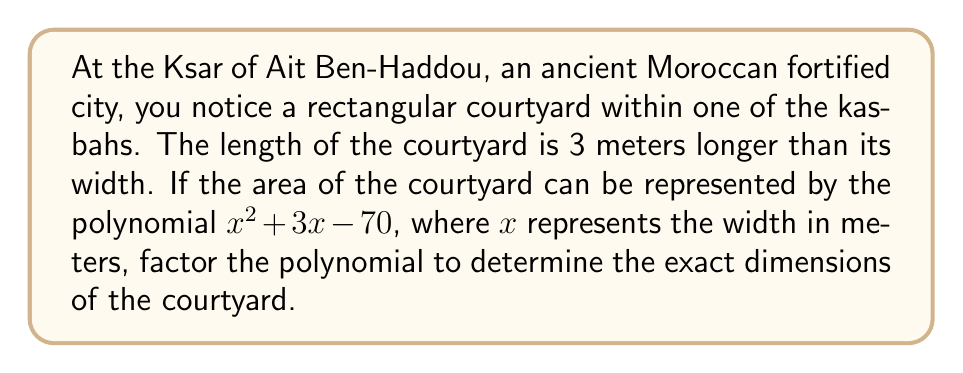What is the answer to this math problem? To solve this problem, we need to factor the given polynomial $x^2 + 3x - 70$ and interpret the results in the context of the courtyard's dimensions.

Step 1: Identify the polynomial
We have $ax^2 + bx + c$ where $a=1$, $b=3$, and $c=-70$.

Step 2: Use the ac-method for factoring
1) Multiply $a \cdot c = 1 \cdot (-70) = -70$
2) Find two numbers that multiply to give -70 and add to give 3 (the coefficient of x)
   These numbers are 10 and -7

Step 3: Rewrite the middle term
$x^2 + 3x - 70 = x^2 + 10x - 7x - 70$

Step 4: Factor by grouping
$(x^2 + 10x) + (-7x - 70)$
$x(x + 10) - 7(x + 10)$
$(x - 7)(x + 10)$

Step 5: Interpret the results
The factors are $(x - 7)$ and $(x + 10)$. 
Setting each factor to zero:
$x - 7 = 0$ implies $x = 7$
$x + 10 = 0$ implies $x = -10$ (which we can discard as a negative width is not possible)

Therefore, the width of the courtyard is 7 meters.
Since the length is 3 meters longer than the width, the length is $7 + 3 = 10$ meters.

We can verify:
Area = length × width = 10 × 7 = 70 square meters
This matches our original equation when $x = 7$:
$7^2 + 3(7) - 70 = 49 + 21 - 70 = 0$
Answer: The dimensions of the courtyard are 7 meters wide and 10 meters long. 